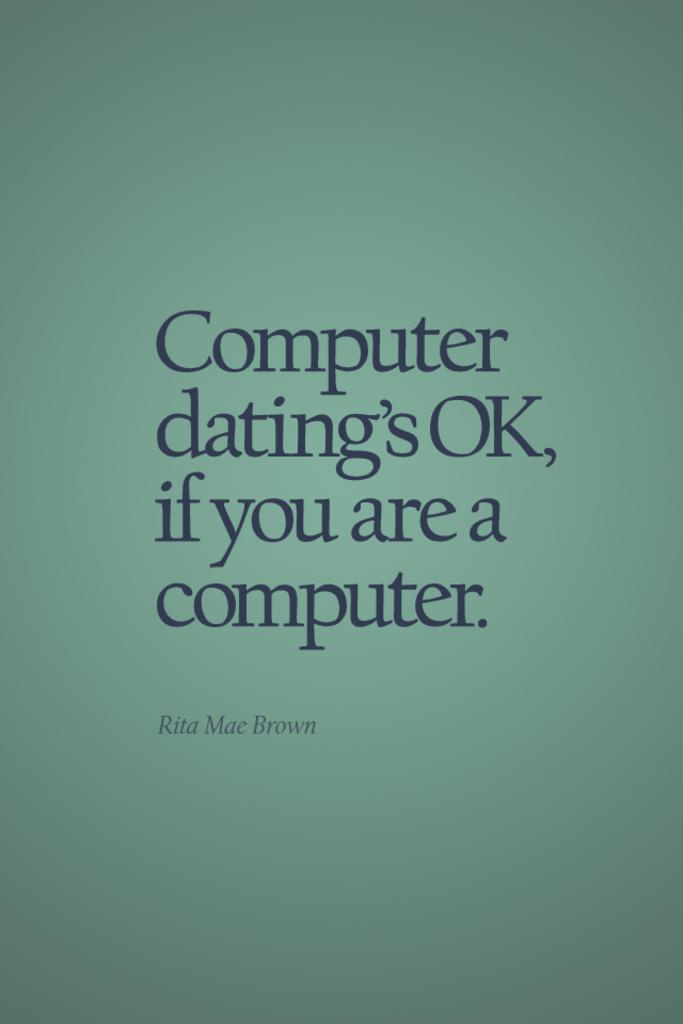<image>
Write a terse but informative summary of the picture. Computer dating's OK, if you are a computer. 